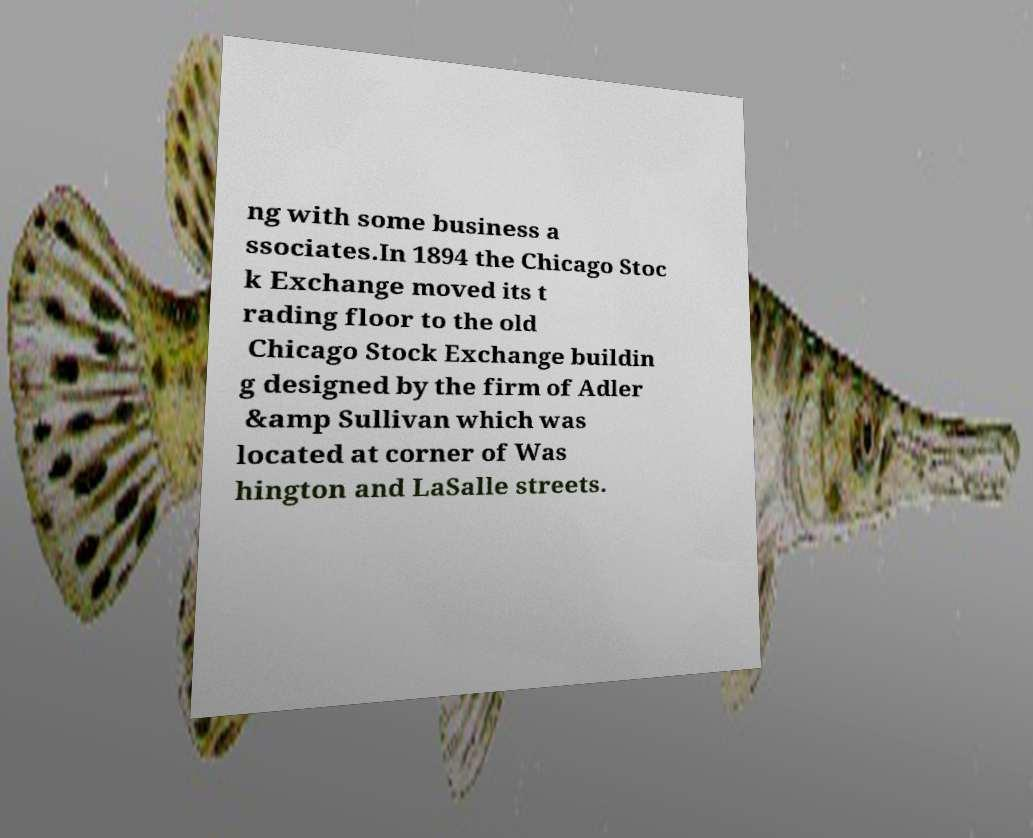Could you extract and type out the text from this image? ng with some business a ssociates.In 1894 the Chicago Stoc k Exchange moved its t rading floor to the old Chicago Stock Exchange buildin g designed by the firm of Adler &amp Sullivan which was located at corner of Was hington and LaSalle streets. 